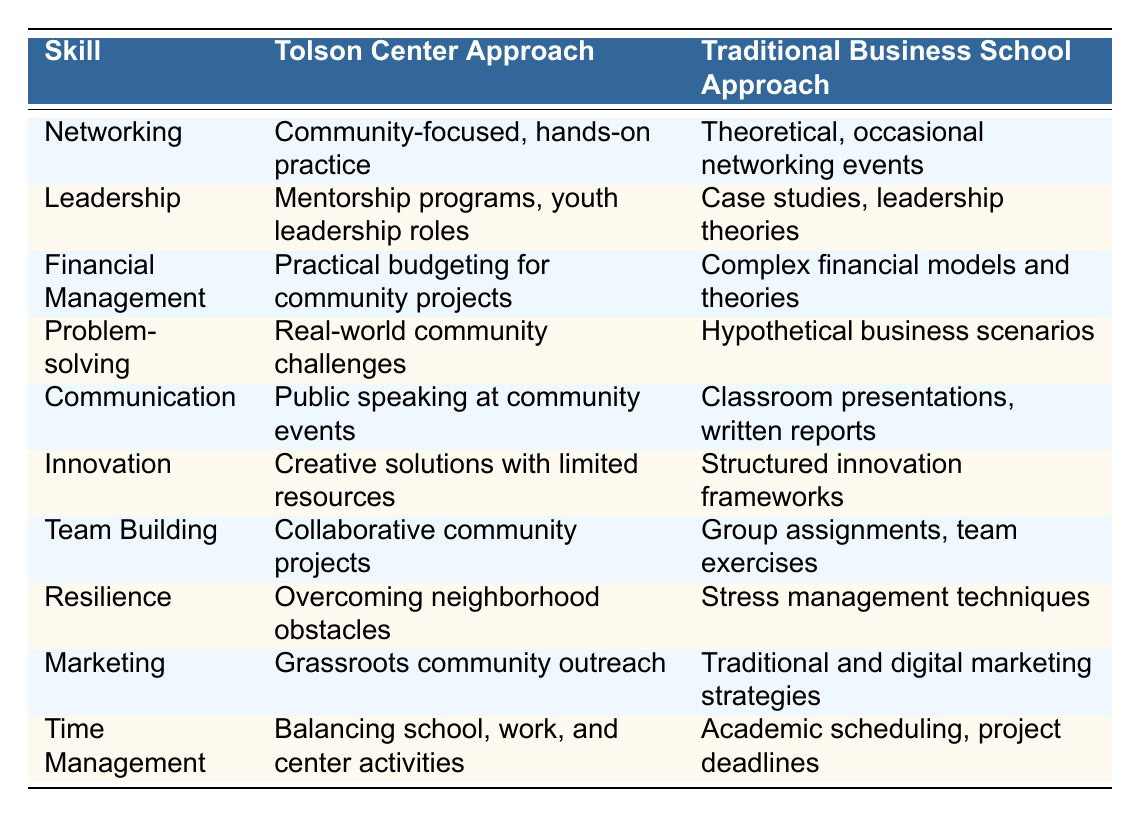What is the approach to networking at the Tolson Center? The table indicates that the Tolson Center approach to networking is community-focused and involves hands-on practice, as compared to the theoretical approach of traditional business schools.
Answer: Community-focused, hands-on practice Which skill focuses on overcoming obstacles? The table shows that resilience is the skill associated with overcoming neighborhood obstacles, highlighting the Tolson Center's practical approach to building this skill.
Answer: Resilience Does the Tolson Center teach complex financial models? According to the table, the Tolson Center approach to financial management involves practical budgeting for community projects, while traditional business schools teach complex financial models. Thus, the answer is no.
Answer: No How does the Tolson Center's communication approach differ from traditional business schools? The Tolson Center emphasizes public speaking at community events for communication skills, whereas traditional business schools focus on classroom presentations and written reports, making them quite different in focus and application.
Answer: It focuses on public speaking, unlike the traditional approach Which approach to leadership includes mentorship programs? The table clearly states that the Tolson Center approach includes mentorship programs, while the traditional business school approach relies on case studies and theories, indicating a more hands-on approach specific to the Tolson Center.
Answer: Tolson Center approach How does the marketing skill at the Tolson Center compare with that of traditional business schools? The Tolson Center focuses on grassroots community outreach for marketing, contrasting with the traditional business school which covers both traditional and digital marketing strategies, revealing a differences in the strategy emphasis.
Answer: Tolson Center focuses on grassroots outreach Which skill approaches at the Tolson Center emphasize real-world applications? From the table, problem-solving is emphasized through real-world community challenges, showcasing a practical application of skills, while traditional business schools rely on hypothetical scenarios.
Answer: Problem-solving In terms of team building, which center emphasizes collaborative projects? The Tolson Center approach emphasizes collaborative community projects for team building, contrasting with group assignments and exercises found in traditional business schools.
Answer: Tolson Center Is the financial management approach at traditional business schools generally simpler than at the Tolson Center? The table indicates that traditional business schools focus on complex financial models and theories, while the Tolson Center takes a practical route with budgeting, suggesting that the traditional approach is indeed more complex.
Answer: Yes Which center teaches time management through balancing multiple activities? The table shows that the Tolson Center teaches time management by balancing school, work, and center activities, while traditional business schools focus on academic scheduling, revealing a practical teaching method at the Tolson Center.
Answer: Tolson Center 